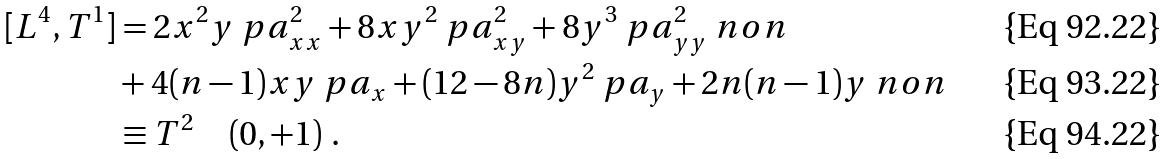Convert formula to latex. <formula><loc_0><loc_0><loc_500><loc_500>[ L ^ { 4 } , T ^ { 1 } ] & = 2 x ^ { 2 } y \ p a _ { x x } ^ { 2 } + 8 x y ^ { 2 } \ p a _ { x y } ^ { 2 } + 8 y ^ { 3 } \ p a _ { y y } ^ { 2 } \ n o n \\ & + 4 ( n - 1 ) x y \ p a _ { x } + ( 1 2 - 8 n ) y ^ { 2 } \ p a _ { y } + 2 n ( n - 1 ) y \ n o n \\ & \equiv T ^ { 2 } \quad ( 0 , + 1 ) \ .</formula> 